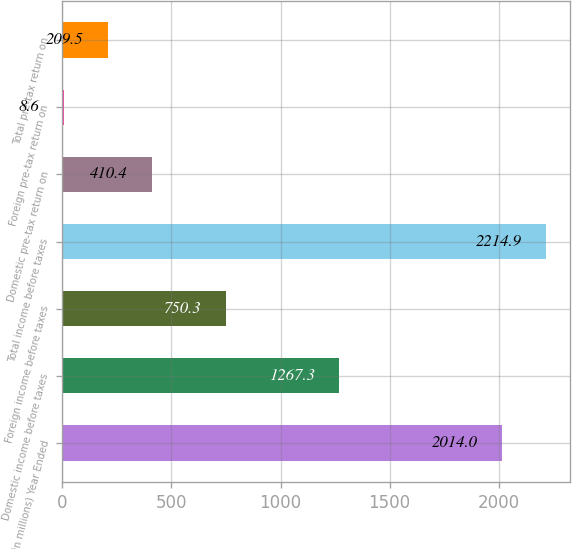<chart> <loc_0><loc_0><loc_500><loc_500><bar_chart><fcel>( in millions) Year Ended<fcel>Domestic income before taxes<fcel>Foreign income before taxes<fcel>Total income before taxes<fcel>Domestic pre-tax return on<fcel>Foreign pre-tax return on<fcel>Total pre-tax return on<nl><fcel>2014<fcel>1267.3<fcel>750.3<fcel>2214.9<fcel>410.4<fcel>8.6<fcel>209.5<nl></chart> 